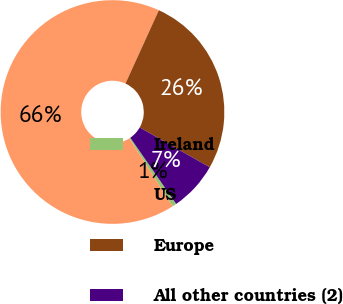Convert chart to OTSL. <chart><loc_0><loc_0><loc_500><loc_500><pie_chart><fcel>Ireland<fcel>US<fcel>Europe<fcel>All other countries (2)<nl><fcel>0.61%<fcel>65.83%<fcel>26.42%<fcel>7.13%<nl></chart> 